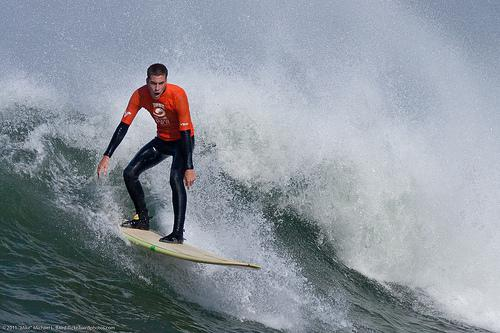Question: what is the person doing?
Choices:
A. Surfing.
B. Talking.
C. Sleeping.
D. Playing video games.
Answer with the letter. Answer: A Question: when was this picture taken?
Choices:
A. During the day.
B. After the party.
C. When they were at the casino.
D. Christmas.
Answer with the letter. Answer: A Question: what is the person standing on?
Choices:
A. The grass.
B. The chair.
C. A surfboard.
D. The ladder.
Answer with the letter. Answer: C Question: where is the person surfing?
Choices:
A. In the ocean.
B. Near the beach.
C. On the waves.
D. Off the coast.
Answer with the letter. Answer: A Question: what color are the surfer's pants?
Choices:
A. Blue.
B. Yellow.
C. Black.
D. Green.
Answer with the letter. Answer: C Question: how many people are surfing?
Choices:
A. One.
B. Two.
C. Three.
D. Four.
Answer with the letter. Answer: A Question: how many dinosaurs are in the picture?
Choices:
A. One.
B. Two.
C. Zero.
D. Four.
Answer with the letter. Answer: C 